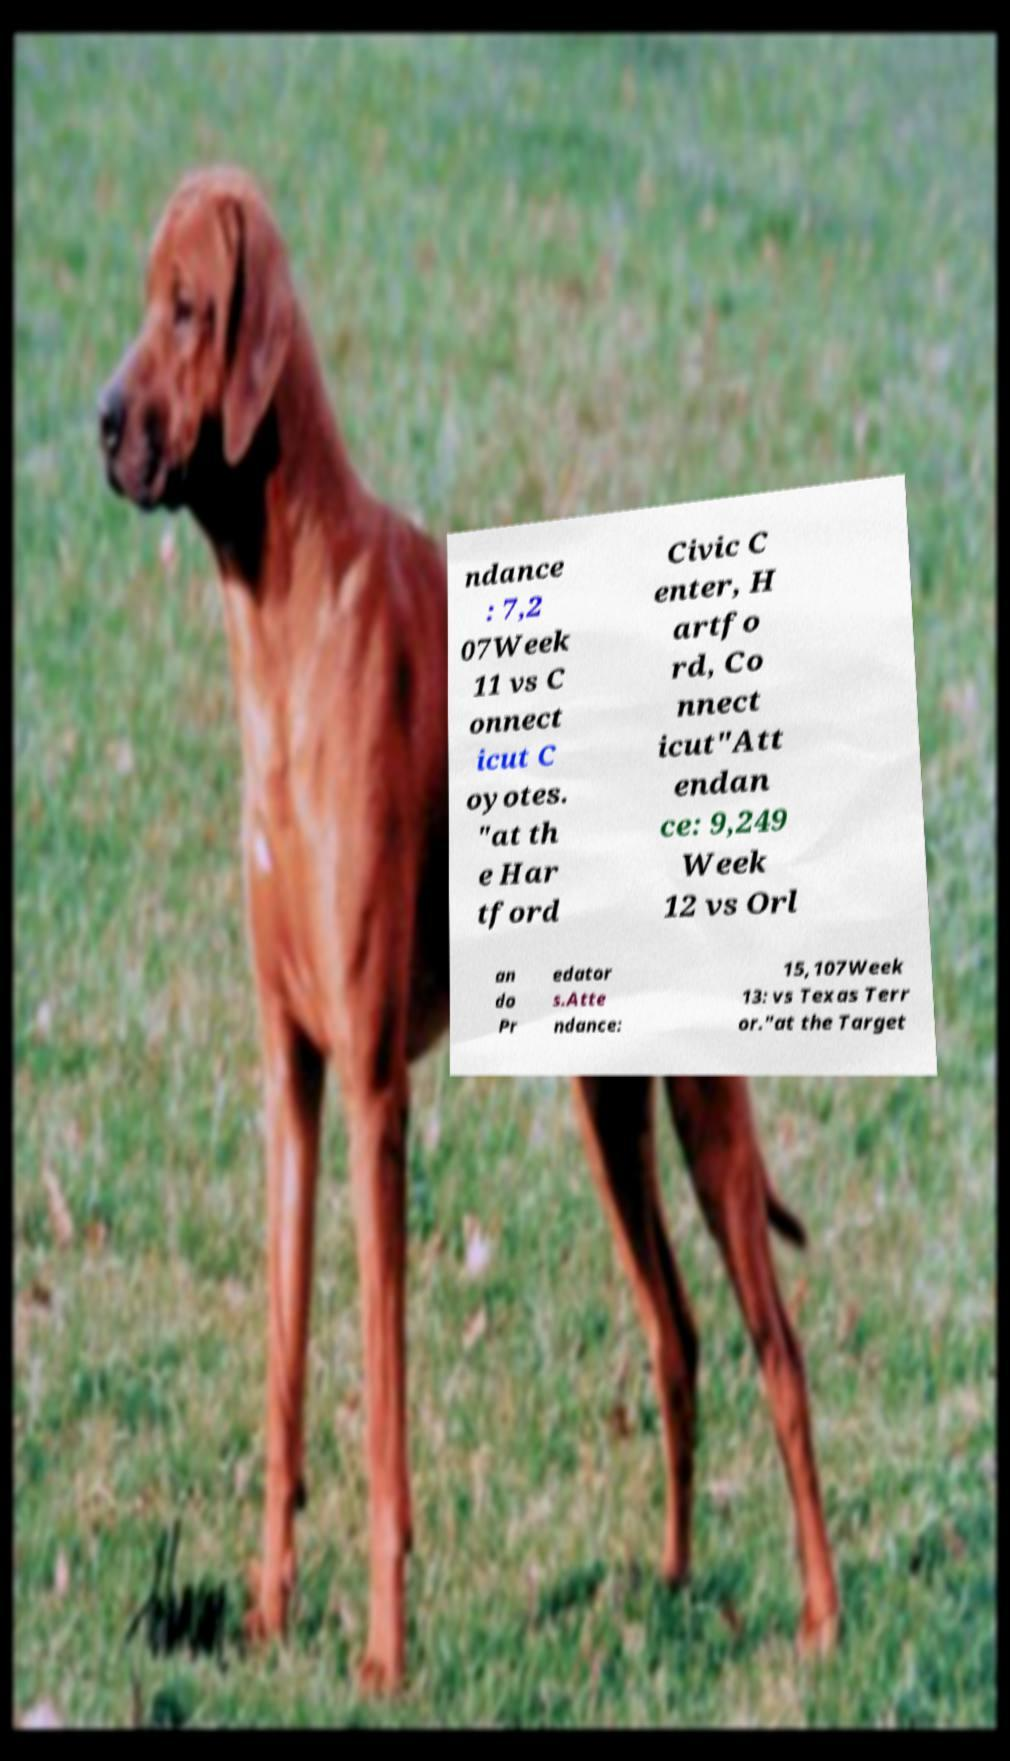Please identify and transcribe the text found in this image. ndance : 7,2 07Week 11 vs C onnect icut C oyotes. "at th e Har tford Civic C enter, H artfo rd, Co nnect icut"Att endan ce: 9,249 Week 12 vs Orl an do Pr edator s.Atte ndance: 15,107Week 13: vs Texas Terr or."at the Target 